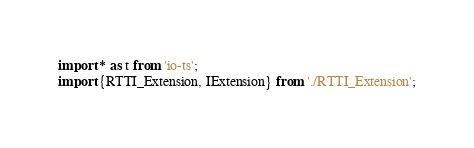<code> <loc_0><loc_0><loc_500><loc_500><_TypeScript_>import * as t from 'io-ts';
import {RTTI_Extension, IExtension} from './RTTI_Extension';</code> 